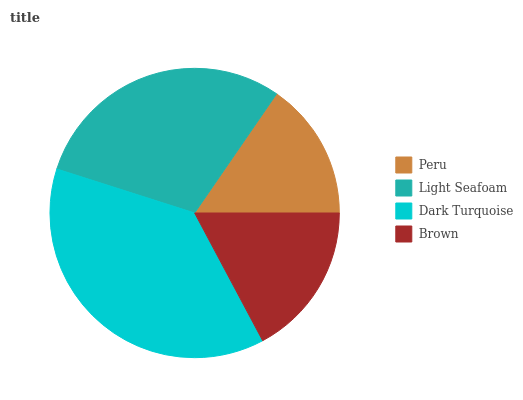Is Peru the minimum?
Answer yes or no. Yes. Is Dark Turquoise the maximum?
Answer yes or no. Yes. Is Light Seafoam the minimum?
Answer yes or no. No. Is Light Seafoam the maximum?
Answer yes or no. No. Is Light Seafoam greater than Peru?
Answer yes or no. Yes. Is Peru less than Light Seafoam?
Answer yes or no. Yes. Is Peru greater than Light Seafoam?
Answer yes or no. No. Is Light Seafoam less than Peru?
Answer yes or no. No. Is Light Seafoam the high median?
Answer yes or no. Yes. Is Brown the low median?
Answer yes or no. Yes. Is Dark Turquoise the high median?
Answer yes or no. No. Is Dark Turquoise the low median?
Answer yes or no. No. 